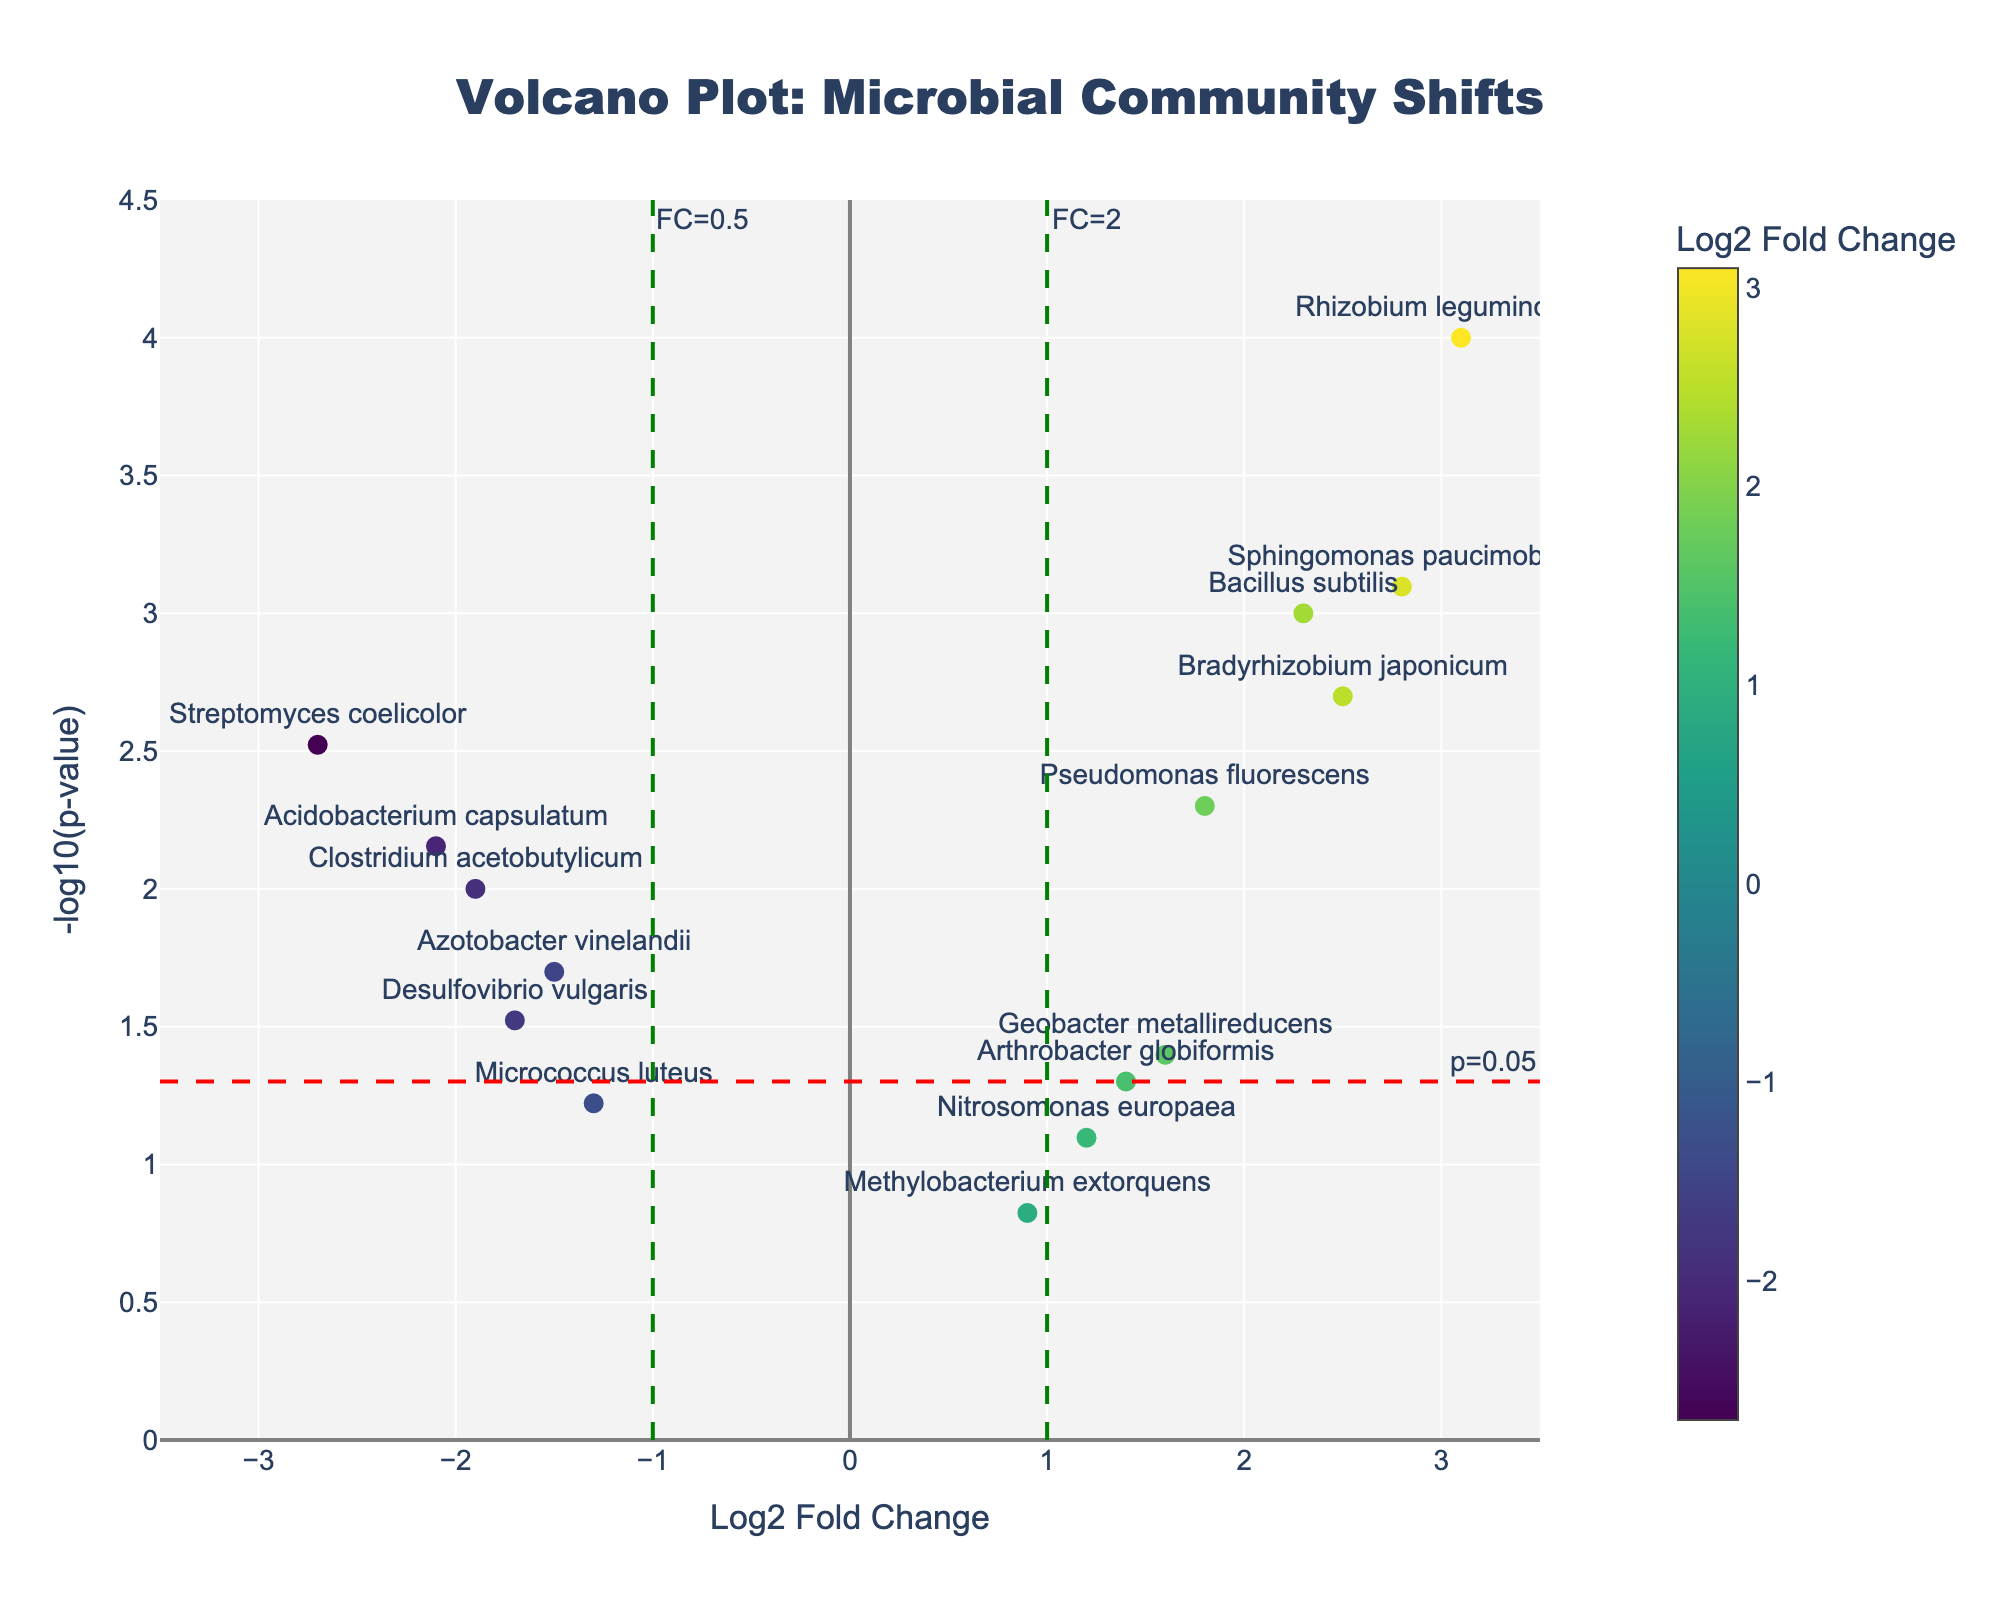What is the title of the plot? The title is always displayed at the top of the plot. It gives an overview of what is being visualized.
Answer: "Volcano Plot: Microbial Community Shifts" How many species have a significant p-value less than 0.05? To find this, look for points above the horizontal red dashed line, as it marks the threshold for p=0.05. Count the points above this line.
Answer: 11 Which species has the highest -log10(p-value) and what is its Log2 Fold Change? The -log10(p-value) indicates significance; the higher it is, the more significant. Locate the species represented by the topmost point.
Answer: Rhizobium leguminosarum; Log2FC: 3.1 What is the Log2 Fold Change value for Bacillus subtilis? Locate the label for Bacillus subtilis on the scatter plot and read its x-value, representing the Log2 Fold Change.
Answer: 2.3 Among the species with significant p-values (less than 0.05), which one has the smallest Log2 Fold Change? First, filter species above the red line for p=0.05 significance. Then, find the point closest to the vertical axis (smallest absolute value of Log2 Fold Change).
Answer: Nitrosomonas europaea What is the color indicating significant upregulated species in the plot? Upregulated species have positive Log2 Fold Change values. Check the color bar on the right for colors corresponding to positive values.
Answer: Green to yellow shades Which species are downregulated with a significant p-value? Downregulated species have negative Log2 Fold Changes. Look below the x-axis with points above the red line.
Answer: Azotobacter vinelandii, Streptomyces coelicolor, Clostridium acetobutylicum, Acidobacterium capsulatum, Desulfovibrio vulgaris How many species have a Log2 Fold Change greater than 2.5? Identify points with x-values greater than 2.5 and count them, considering significant p-values (above red line).
Answer: 3 Compare Bradyrhizobium japonicum and Bacillus subtilis, which has a higher -log10(p-value)? Check the y-values for Bradyrhizobium japonicum and Bacillus subtilis, then compare their heights on the plot.
Answer: Bradyrhizobium japonicum Of the species with p-values less than 0.01, which has the lowest Log2 Fold Change? Filter to species above the red line with y-values corresponding to p<0.01, then identify which has the smallest x-value.
Answer: Streptomyces coelicolor 